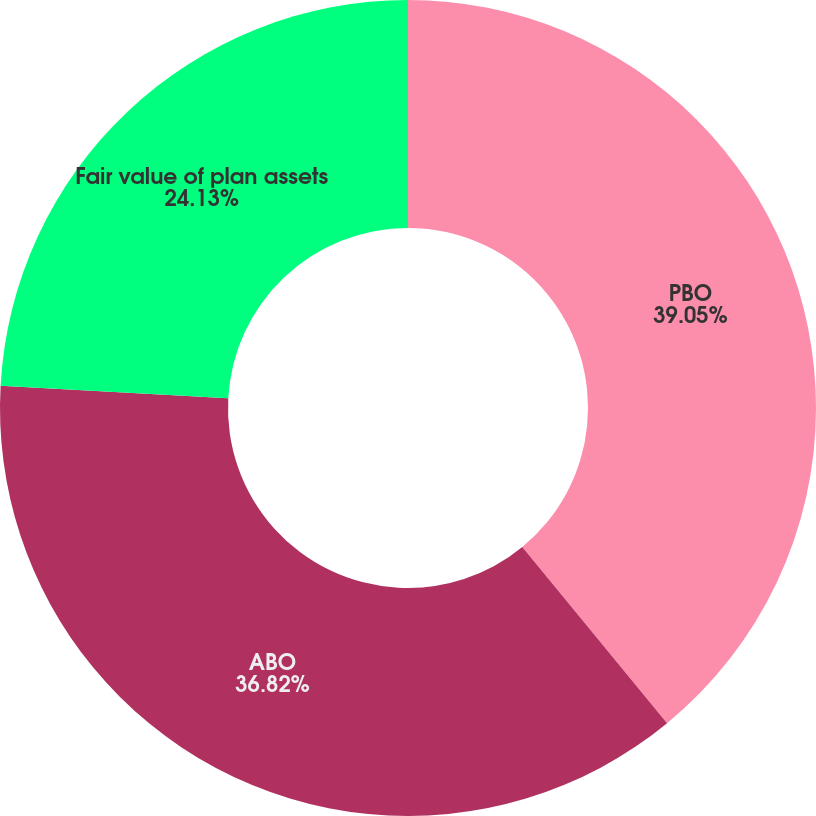Convert chart. <chart><loc_0><loc_0><loc_500><loc_500><pie_chart><fcel>PBO<fcel>ABO<fcel>Fair value of plan assets<nl><fcel>39.05%<fcel>36.82%<fcel>24.13%<nl></chart> 